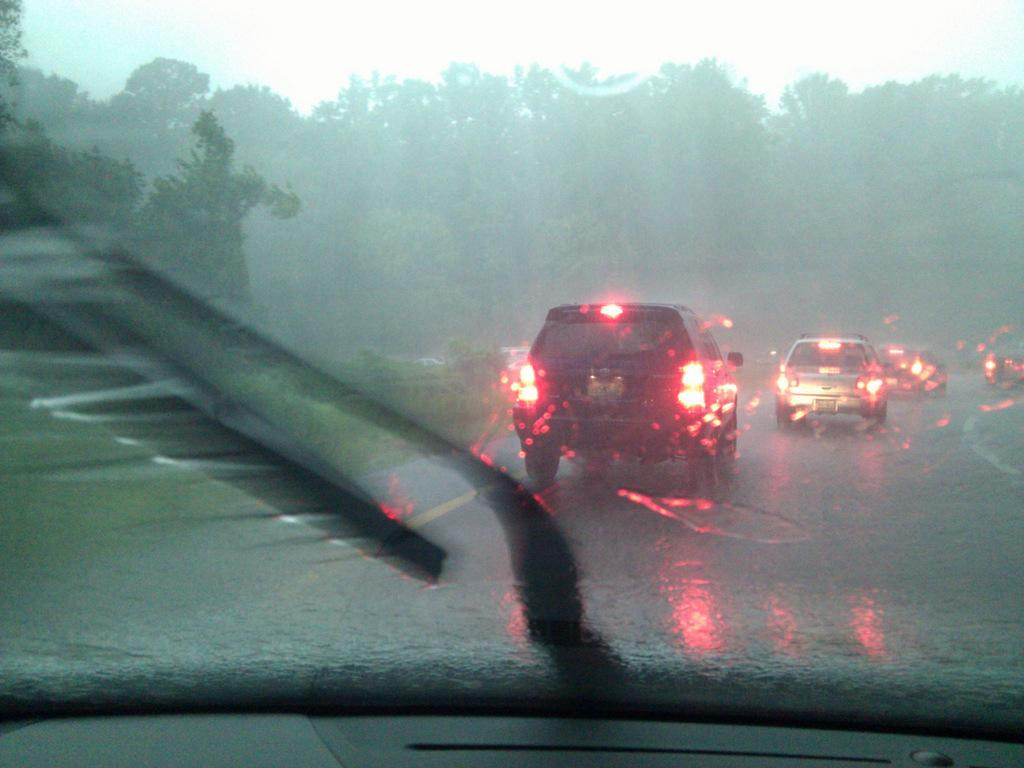What can be seen on the road in the image? There are vehicles on the road in the image. What type of natural scenery is visible in the background of the image? There are trees visible in the background of the image. What type of bell can be heard ringing in the image? There is no bell present in the image, and therefore no sound can be heard. 